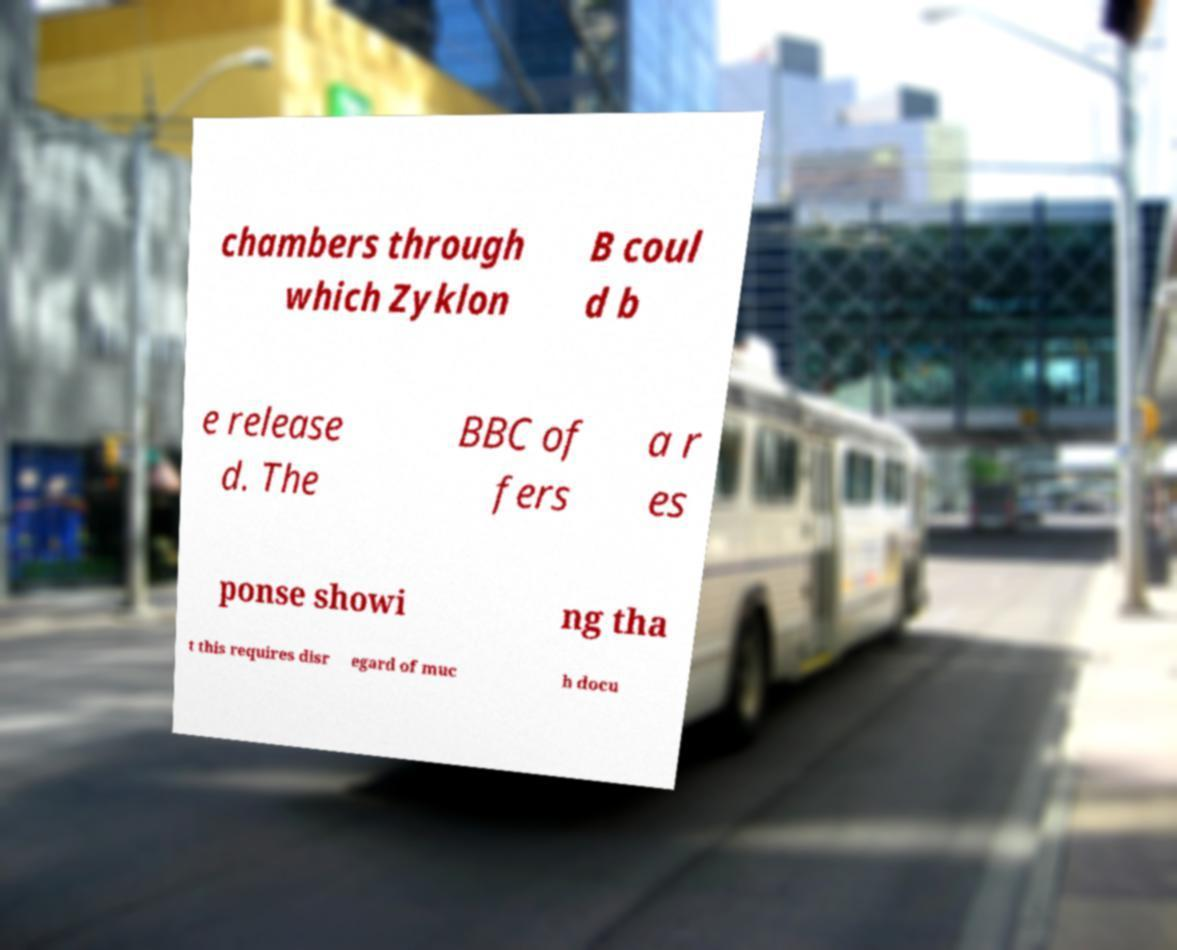I need the written content from this picture converted into text. Can you do that? chambers through which Zyklon B coul d b e release d. The BBC of fers a r es ponse showi ng tha t this requires disr egard of muc h docu 